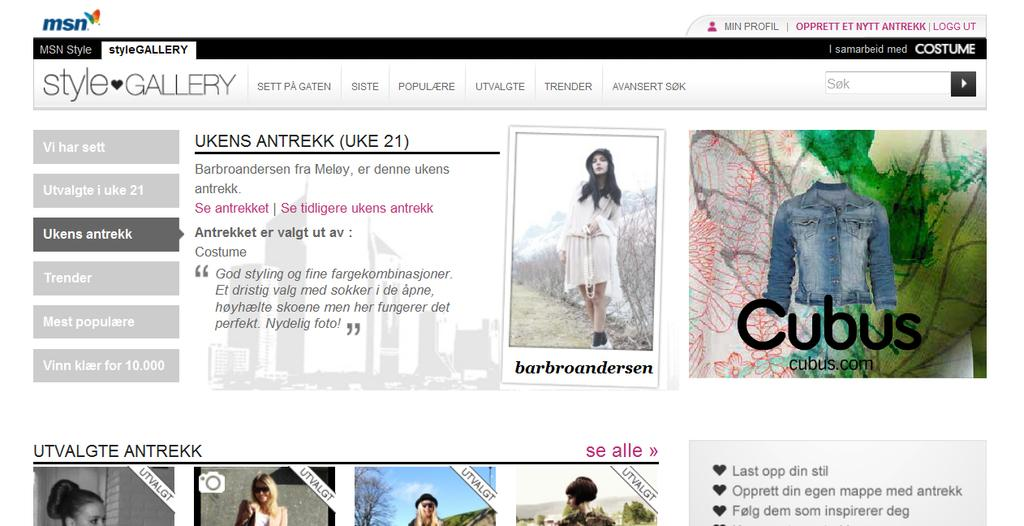What is the main subject of the image? The main subject of the image is a web page. What types of content can be found on the web page? The web page contains pictures and text. What type of drink is being offered in the wilderness depicted on the web page? There is no depiction of a wilderness or any drink on the web page; it only contains pictures and text. 